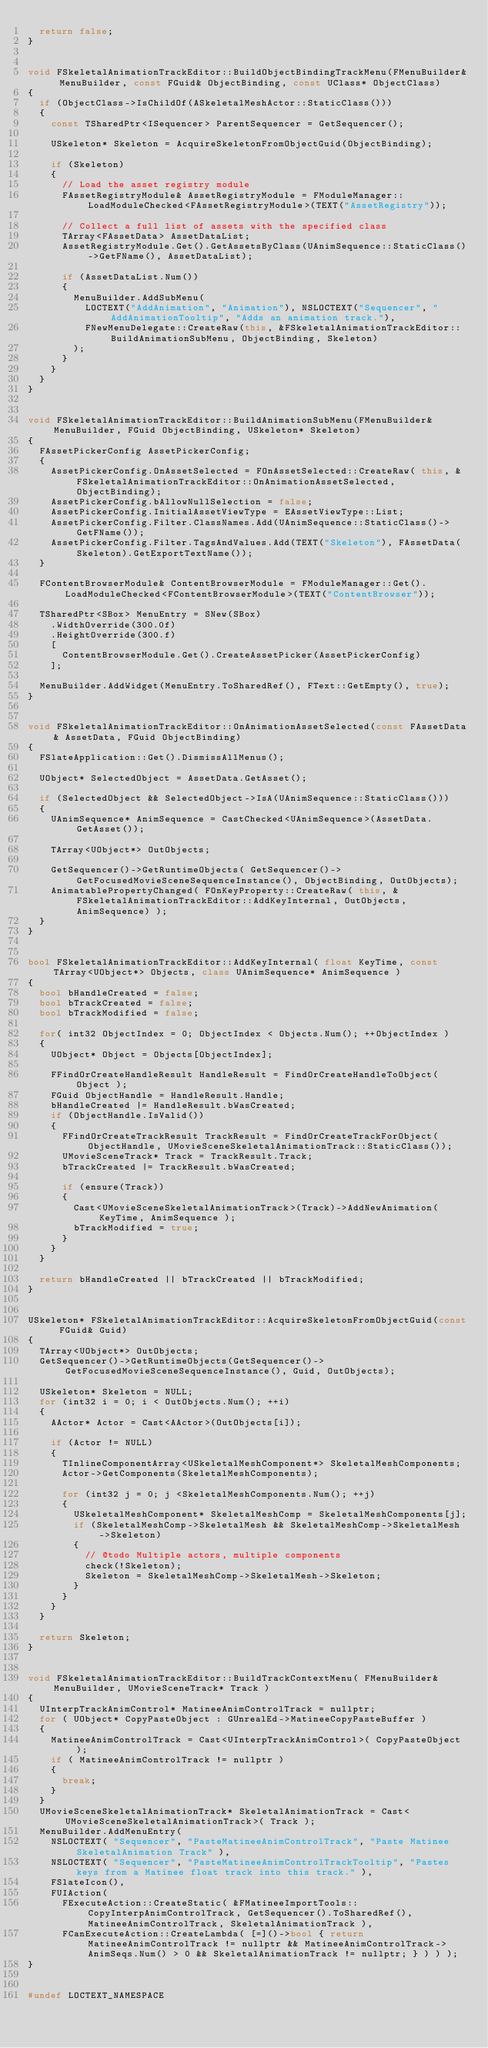<code> <loc_0><loc_0><loc_500><loc_500><_C++_>	return false;
}


void FSkeletalAnimationTrackEditor::BuildObjectBindingTrackMenu(FMenuBuilder& MenuBuilder, const FGuid& ObjectBinding, const UClass* ObjectClass)
{
	if (ObjectClass->IsChildOf(ASkeletalMeshActor::StaticClass()))
	{
		const TSharedPtr<ISequencer> ParentSequencer = GetSequencer();

		USkeleton* Skeleton = AcquireSkeletonFromObjectGuid(ObjectBinding);

		if (Skeleton)
		{
			// Load the asset registry module
			FAssetRegistryModule& AssetRegistryModule = FModuleManager::LoadModuleChecked<FAssetRegistryModule>(TEXT("AssetRegistry"));

			// Collect a full list of assets with the specified class
			TArray<FAssetData> AssetDataList;
			AssetRegistryModule.Get().GetAssetsByClass(UAnimSequence::StaticClass()->GetFName(), AssetDataList);

			if (AssetDataList.Num())
			{
				MenuBuilder.AddSubMenu(
					LOCTEXT("AddAnimation", "Animation"), NSLOCTEXT("Sequencer", "AddAnimationTooltip", "Adds an animation track."),
					FNewMenuDelegate::CreateRaw(this, &FSkeletalAnimationTrackEditor::BuildAnimationSubMenu, ObjectBinding, Skeleton)
				);
			}
		}
	}
}


void FSkeletalAnimationTrackEditor::BuildAnimationSubMenu(FMenuBuilder& MenuBuilder, FGuid ObjectBinding, USkeleton* Skeleton)
{
	FAssetPickerConfig AssetPickerConfig;
	{
		AssetPickerConfig.OnAssetSelected = FOnAssetSelected::CreateRaw( this, &FSkeletalAnimationTrackEditor::OnAnimationAssetSelected, ObjectBinding);
		AssetPickerConfig.bAllowNullSelection = false;
		AssetPickerConfig.InitialAssetViewType = EAssetViewType::List;
		AssetPickerConfig.Filter.ClassNames.Add(UAnimSequence::StaticClass()->GetFName());
		AssetPickerConfig.Filter.TagsAndValues.Add(TEXT("Skeleton"), FAssetData(Skeleton).GetExportTextName());
	}

	FContentBrowserModule& ContentBrowserModule = FModuleManager::Get().LoadModuleChecked<FContentBrowserModule>(TEXT("ContentBrowser"));

	TSharedPtr<SBox> MenuEntry = SNew(SBox)
		.WidthOverride(300.0f)
		.HeightOverride(300.f)
		[
			ContentBrowserModule.Get().CreateAssetPicker(AssetPickerConfig)
		];

	MenuBuilder.AddWidget(MenuEntry.ToSharedRef(), FText::GetEmpty(), true);
}


void FSkeletalAnimationTrackEditor::OnAnimationAssetSelected(const FAssetData& AssetData, FGuid ObjectBinding)
{
	FSlateApplication::Get().DismissAllMenus();

	UObject* SelectedObject = AssetData.GetAsset();

	if (SelectedObject && SelectedObject->IsA(UAnimSequence::StaticClass()))
	{
		UAnimSequence* AnimSequence = CastChecked<UAnimSequence>(AssetData.GetAsset());

		TArray<UObject*> OutObjects;

		GetSequencer()->GetRuntimeObjects( GetSequencer()->GetFocusedMovieSceneSequenceInstance(), ObjectBinding, OutObjects);
		AnimatablePropertyChanged( FOnKeyProperty::CreateRaw( this, &FSkeletalAnimationTrackEditor::AddKeyInternal, OutObjects, AnimSequence) );
	}
}


bool FSkeletalAnimationTrackEditor::AddKeyInternal( float KeyTime, const TArray<UObject*> Objects, class UAnimSequence* AnimSequence )
{
	bool bHandleCreated = false;
	bool bTrackCreated = false;
	bool bTrackModified = false;

	for( int32 ObjectIndex = 0; ObjectIndex < Objects.Num(); ++ObjectIndex )
	{
		UObject* Object = Objects[ObjectIndex];

		FFindOrCreateHandleResult HandleResult = FindOrCreateHandleToObject( Object );
		FGuid ObjectHandle = HandleResult.Handle;
		bHandleCreated |= HandleResult.bWasCreated;
		if (ObjectHandle.IsValid())
		{
			FFindOrCreateTrackResult TrackResult = FindOrCreateTrackForObject(ObjectHandle, UMovieSceneSkeletalAnimationTrack::StaticClass());
			UMovieSceneTrack* Track = TrackResult.Track;
			bTrackCreated |= TrackResult.bWasCreated;

			if (ensure(Track))
			{
				Cast<UMovieSceneSkeletalAnimationTrack>(Track)->AddNewAnimation( KeyTime, AnimSequence );
				bTrackModified = true;
			}
		}
	}

	return bHandleCreated || bTrackCreated || bTrackModified;
}


USkeleton* FSkeletalAnimationTrackEditor::AcquireSkeletonFromObjectGuid(const FGuid& Guid)
{
	TArray<UObject*> OutObjects;
	GetSequencer()->GetRuntimeObjects(GetSequencer()->GetFocusedMovieSceneSequenceInstance(), Guid, OutObjects);

	USkeleton* Skeleton = NULL;
	for (int32 i = 0; i < OutObjects.Num(); ++i)
	{
		AActor* Actor = Cast<AActor>(OutObjects[i]);

		if (Actor != NULL)
		{
			TInlineComponentArray<USkeletalMeshComponent*> SkeletalMeshComponents;
			Actor->GetComponents(SkeletalMeshComponents);

			for (int32 j = 0; j <SkeletalMeshComponents.Num(); ++j)
			{
				USkeletalMeshComponent* SkeletalMeshComp = SkeletalMeshComponents[j];
				if (SkeletalMeshComp->SkeletalMesh && SkeletalMeshComp->SkeletalMesh->Skeleton)
				{
					// @todo Multiple actors, multiple components
					check(!Skeleton);
					Skeleton = SkeletalMeshComp->SkeletalMesh->Skeleton;
				}
			}
		}
	}

	return Skeleton;
}


void FSkeletalAnimationTrackEditor::BuildTrackContextMenu( FMenuBuilder& MenuBuilder, UMovieSceneTrack* Track )
{
	UInterpTrackAnimControl* MatineeAnimControlTrack = nullptr;
	for ( UObject* CopyPasteObject : GUnrealEd->MatineeCopyPasteBuffer )
	{
		MatineeAnimControlTrack = Cast<UInterpTrackAnimControl>( CopyPasteObject );
		if ( MatineeAnimControlTrack != nullptr )
		{
			break;
		}
	}
	UMovieSceneSkeletalAnimationTrack* SkeletalAnimationTrack = Cast<UMovieSceneSkeletalAnimationTrack>( Track );
	MenuBuilder.AddMenuEntry(
		NSLOCTEXT( "Sequencer", "PasteMatineeAnimControlTrack", "Paste Matinee SkeletalAnimation Track" ),
		NSLOCTEXT( "Sequencer", "PasteMatineeAnimControlTrackTooltip", "Pastes keys from a Matinee float track into this track." ),
		FSlateIcon(),
		FUIAction(
			FExecuteAction::CreateStatic( &FMatineeImportTools::CopyInterpAnimControlTrack, GetSequencer().ToSharedRef(), MatineeAnimControlTrack, SkeletalAnimationTrack ),
			FCanExecuteAction::CreateLambda( [=]()->bool { return MatineeAnimControlTrack != nullptr && MatineeAnimControlTrack->AnimSeqs.Num() > 0 && SkeletalAnimationTrack != nullptr; } ) ) );
}


#undef LOCTEXT_NAMESPACE
</code> 